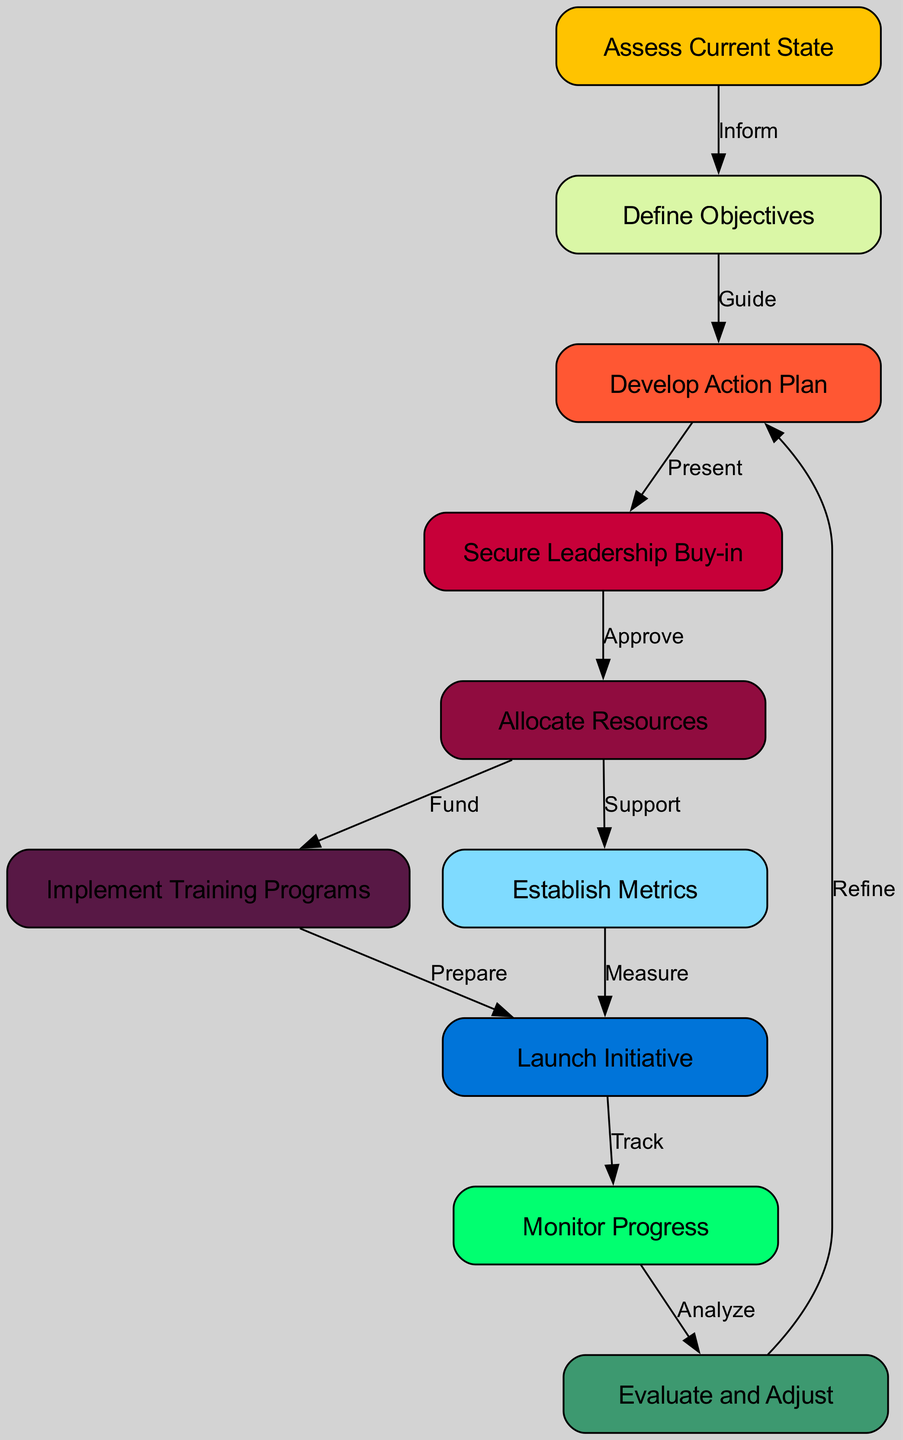What is the first step in the process? The first step in the process is indicated by the node labeled "Assess Current State." This node is the starting point of the flowchart, representing the initial action to be taken.
Answer: Assess Current State How many total nodes are there in the diagram? To find the total number of nodes, we need to count all the distinct nodes listed. There are ten nodes in total as provided in the data.
Answer: 10 What step follows "Define Objectives"? From the flow of the chart, "Define Objectives" is followed by a node labeled "Develop Action Plan." The connection is directly noted in the edges.
Answer: Develop Action Plan What is the last step before evaluation? The last step indicated before moving on to evaluation is "Monitor Progress." This step is directly connected to "Evaluate and Adjust," which is the evaluation phase.
Answer: Monitor Progress How many edges are there in total? The total number of edges is determined by counting the connections between the nodes, which are provided in the data. There are ten edges connecting the nodes in the diagram.
Answer: 10 What does the edge from "Implement Training Programs" to "Launch Initiative" signify? This edge represents the relationship labeled "Prepare," which indicates that preparing training programs is a prerequisite for launching the initiative.
Answer: Prepare Which step requires securing resources? "Allocate Resources" is the step that specifically requires resources to be secured and allocated. It directly follows the "Secure Leadership Buy-in" step in the process flow.
Answer: Allocate Resources What is the feedback loop present in the diagram? The feedback loop is established from "Evaluate and Adjust" back to "Develop Action Plan," indicating a cyclical process where evaluation can lead to adjustments in the action plan.
Answer: Develop Action Plan What is the relationship between "Establish Metrics" and "Launch Initiative"? The relationship is indicated by the edge labeled "Measure," showing that establishing metrics is crucial for measuring the success of the launch initiative.
Answer: Measure 